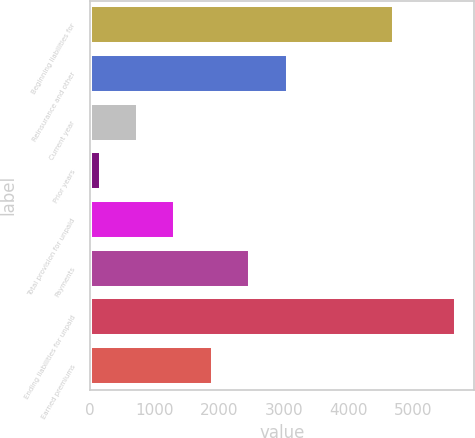Convert chart. <chart><loc_0><loc_0><loc_500><loc_500><bar_chart><fcel>Beginning liabilities for<fcel>Reinsurance and other<fcel>Current year<fcel>Prior years<fcel>Total provision for unpaid<fcel>Payments<fcel>Ending liabilities for unpaid<fcel>Earned premiums<nl><fcel>4704.8<fcel>3059<fcel>747.8<fcel>170<fcel>1325.6<fcel>2481.2<fcel>5655<fcel>1903.4<nl></chart> 